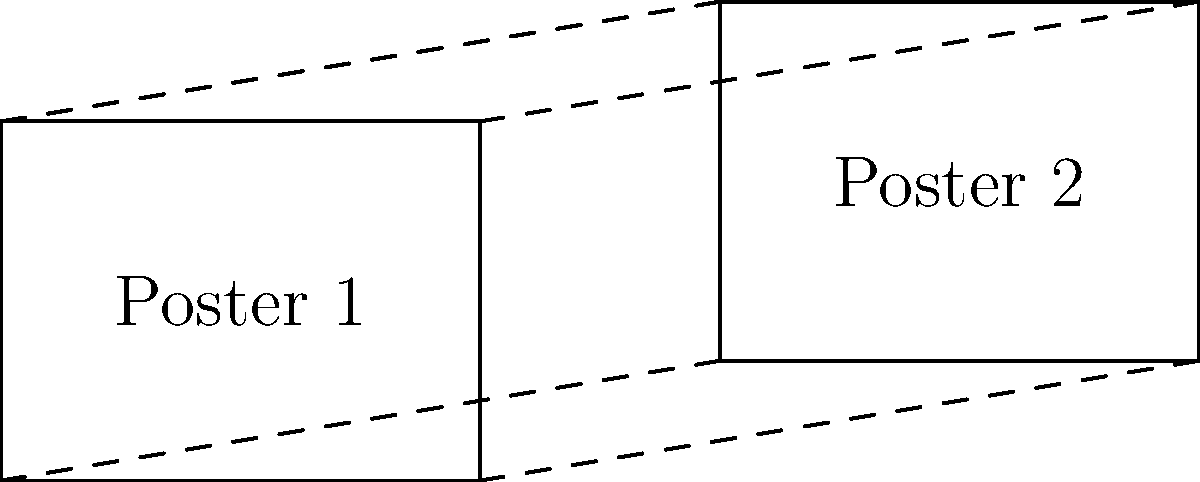In your latest movie poster design, you've created two rectangular posters as shown in the diagram. If Poster 1 has a width of 4 units and a height of 3 units, and Poster 2 is congruent to Poster 1, what is the area of Poster 2 in square units? To solve this problem, let's follow these steps:

1) First, recall that congruent shapes have the same size and shape. This means that Poster 2 has the same dimensions as Poster 1.

2) We're given that Poster 1 has:
   - Width = 4 units
   - Height = 3 units

3) Since Poster 2 is congruent to Poster 1, it also has:
   - Width = 4 units
   - Height = 3 units

4) To find the area of a rectangle, we use the formula:
   $$A = w \times h$$
   where $A$ is the area, $w$ is the width, and $h$ is the height.

5) Substituting the values:
   $$A = 4 \times 3 = 12$$

Therefore, the area of Poster 2 is 12 square units.
Answer: 12 square units 